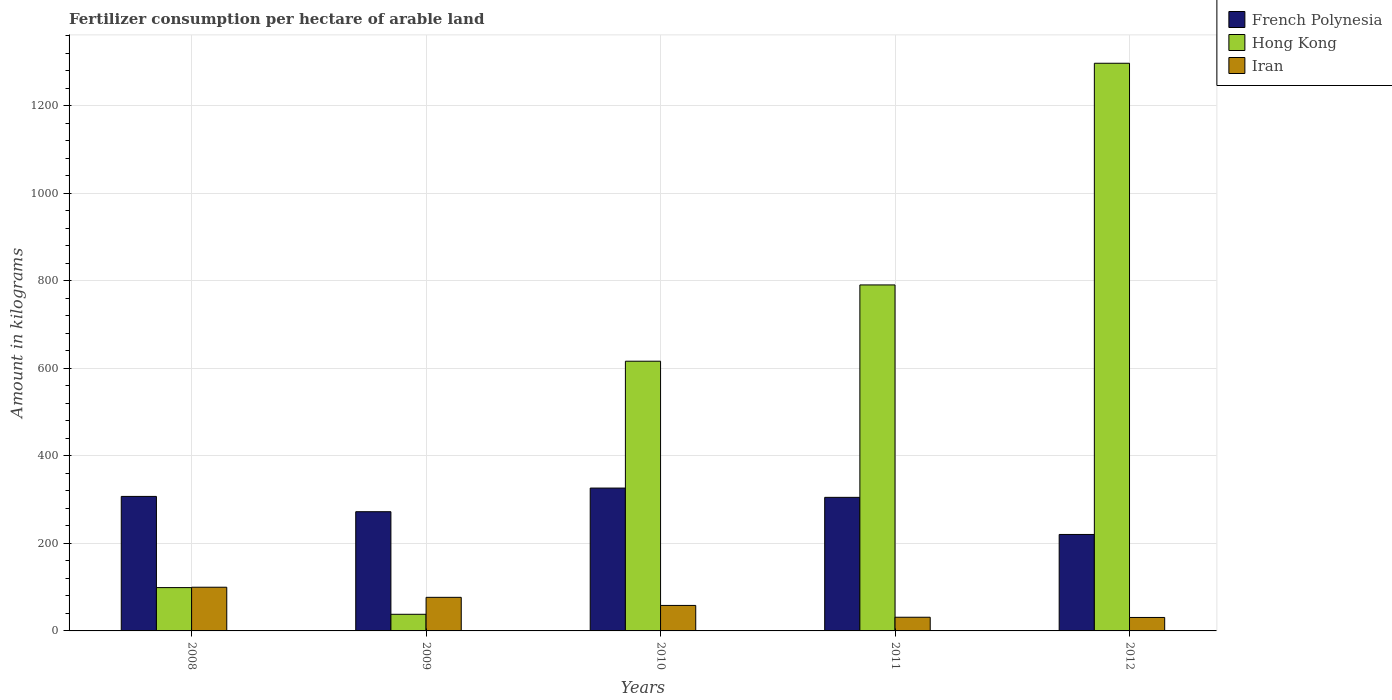How many bars are there on the 1st tick from the left?
Your response must be concise. 3. How many bars are there on the 2nd tick from the right?
Ensure brevity in your answer.  3. What is the label of the 5th group of bars from the left?
Keep it short and to the point. 2012. What is the amount of fertilizer consumption in French Polynesia in 2009?
Give a very brief answer. 272.4. Across all years, what is the maximum amount of fertilizer consumption in Hong Kong?
Your answer should be compact. 1297.1. Across all years, what is the minimum amount of fertilizer consumption in Hong Kong?
Give a very brief answer. 38. In which year was the amount of fertilizer consumption in Iran minimum?
Provide a short and direct response. 2012. What is the total amount of fertilizer consumption in Iran in the graph?
Provide a succinct answer. 296.86. What is the difference between the amount of fertilizer consumption in Hong Kong in 2009 and that in 2010?
Provide a succinct answer. -578.29. What is the difference between the amount of fertilizer consumption in Hong Kong in 2010 and the amount of fertilizer consumption in French Polynesia in 2009?
Provide a succinct answer. 343.89. What is the average amount of fertilizer consumption in Iran per year?
Your answer should be very brief. 59.37. In the year 2012, what is the difference between the amount of fertilizer consumption in Iran and amount of fertilizer consumption in Hong Kong?
Make the answer very short. -1266.33. In how many years, is the amount of fertilizer consumption in Iran greater than 960 kg?
Provide a succinct answer. 0. What is the ratio of the amount of fertilizer consumption in French Polynesia in 2009 to that in 2011?
Your answer should be compact. 0.89. Is the amount of fertilizer consumption in Hong Kong in 2009 less than that in 2010?
Keep it short and to the point. Yes. Is the difference between the amount of fertilizer consumption in Iran in 2009 and 2010 greater than the difference between the amount of fertilizer consumption in Hong Kong in 2009 and 2010?
Offer a very short reply. Yes. What is the difference between the highest and the second highest amount of fertilizer consumption in Iran?
Provide a short and direct response. 23.1. What is the difference between the highest and the lowest amount of fertilizer consumption in Iran?
Offer a very short reply. 69.08. In how many years, is the amount of fertilizer consumption in Iran greater than the average amount of fertilizer consumption in Iran taken over all years?
Ensure brevity in your answer.  2. What does the 3rd bar from the left in 2008 represents?
Make the answer very short. Iran. What does the 3rd bar from the right in 2008 represents?
Your response must be concise. French Polynesia. Is it the case that in every year, the sum of the amount of fertilizer consumption in French Polynesia and amount of fertilizer consumption in Hong Kong is greater than the amount of fertilizer consumption in Iran?
Give a very brief answer. Yes. How many bars are there?
Provide a succinct answer. 15. Does the graph contain any zero values?
Provide a short and direct response. No. Does the graph contain grids?
Your response must be concise. Yes. Where does the legend appear in the graph?
Your response must be concise. Top right. What is the title of the graph?
Keep it short and to the point. Fertilizer consumption per hectare of arable land. What is the label or title of the Y-axis?
Your answer should be very brief. Amount in kilograms. What is the Amount in kilograms of French Polynesia in 2008?
Give a very brief answer. 307.33. What is the Amount in kilograms of Iran in 2008?
Your answer should be very brief. 99.85. What is the Amount in kilograms in French Polynesia in 2009?
Provide a short and direct response. 272.4. What is the Amount in kilograms of Iran in 2009?
Ensure brevity in your answer.  76.74. What is the Amount in kilograms in French Polynesia in 2010?
Make the answer very short. 326.4. What is the Amount in kilograms of Hong Kong in 2010?
Provide a succinct answer. 616.29. What is the Amount in kilograms of Iran in 2010?
Offer a terse response. 58.25. What is the Amount in kilograms in French Polynesia in 2011?
Your answer should be very brief. 305.2. What is the Amount in kilograms of Hong Kong in 2011?
Make the answer very short. 790.57. What is the Amount in kilograms in Iran in 2011?
Your answer should be very brief. 31.26. What is the Amount in kilograms in French Polynesia in 2012?
Your answer should be very brief. 220.4. What is the Amount in kilograms in Hong Kong in 2012?
Offer a very short reply. 1297.1. What is the Amount in kilograms of Iran in 2012?
Provide a short and direct response. 30.76. Across all years, what is the maximum Amount in kilograms of French Polynesia?
Your answer should be very brief. 326.4. Across all years, what is the maximum Amount in kilograms in Hong Kong?
Your response must be concise. 1297.1. Across all years, what is the maximum Amount in kilograms of Iran?
Keep it short and to the point. 99.85. Across all years, what is the minimum Amount in kilograms of French Polynesia?
Your response must be concise. 220.4. Across all years, what is the minimum Amount in kilograms of Iran?
Ensure brevity in your answer.  30.76. What is the total Amount in kilograms of French Polynesia in the graph?
Your response must be concise. 1431.73. What is the total Amount in kilograms in Hong Kong in the graph?
Give a very brief answer. 2840.95. What is the total Amount in kilograms of Iran in the graph?
Offer a very short reply. 296.86. What is the difference between the Amount in kilograms of French Polynesia in 2008 and that in 2009?
Ensure brevity in your answer.  34.93. What is the difference between the Amount in kilograms of Iran in 2008 and that in 2009?
Give a very brief answer. 23.1. What is the difference between the Amount in kilograms of French Polynesia in 2008 and that in 2010?
Provide a succinct answer. -19.07. What is the difference between the Amount in kilograms of Hong Kong in 2008 and that in 2010?
Provide a short and direct response. -517.29. What is the difference between the Amount in kilograms in Iran in 2008 and that in 2010?
Ensure brevity in your answer.  41.6. What is the difference between the Amount in kilograms in French Polynesia in 2008 and that in 2011?
Give a very brief answer. 2.13. What is the difference between the Amount in kilograms of Hong Kong in 2008 and that in 2011?
Ensure brevity in your answer.  -691.57. What is the difference between the Amount in kilograms of Iran in 2008 and that in 2011?
Keep it short and to the point. 68.59. What is the difference between the Amount in kilograms of French Polynesia in 2008 and that in 2012?
Your answer should be compact. 86.93. What is the difference between the Amount in kilograms in Hong Kong in 2008 and that in 2012?
Your response must be concise. -1198.1. What is the difference between the Amount in kilograms in Iran in 2008 and that in 2012?
Give a very brief answer. 69.08. What is the difference between the Amount in kilograms of French Polynesia in 2009 and that in 2010?
Provide a short and direct response. -54. What is the difference between the Amount in kilograms in Hong Kong in 2009 and that in 2010?
Give a very brief answer. -578.29. What is the difference between the Amount in kilograms of Iran in 2009 and that in 2010?
Keep it short and to the point. 18.49. What is the difference between the Amount in kilograms in French Polynesia in 2009 and that in 2011?
Ensure brevity in your answer.  -32.8. What is the difference between the Amount in kilograms of Hong Kong in 2009 and that in 2011?
Ensure brevity in your answer.  -752.57. What is the difference between the Amount in kilograms in Iran in 2009 and that in 2011?
Provide a short and direct response. 45.48. What is the difference between the Amount in kilograms in Hong Kong in 2009 and that in 2012?
Make the answer very short. -1259.1. What is the difference between the Amount in kilograms of Iran in 2009 and that in 2012?
Make the answer very short. 45.98. What is the difference between the Amount in kilograms of French Polynesia in 2010 and that in 2011?
Make the answer very short. 21.2. What is the difference between the Amount in kilograms in Hong Kong in 2010 and that in 2011?
Keep it short and to the point. -174.29. What is the difference between the Amount in kilograms in Iran in 2010 and that in 2011?
Your response must be concise. 26.99. What is the difference between the Amount in kilograms in French Polynesia in 2010 and that in 2012?
Keep it short and to the point. 106. What is the difference between the Amount in kilograms in Hong Kong in 2010 and that in 2012?
Your answer should be very brief. -680.81. What is the difference between the Amount in kilograms in Iran in 2010 and that in 2012?
Your answer should be compact. 27.49. What is the difference between the Amount in kilograms of French Polynesia in 2011 and that in 2012?
Your response must be concise. 84.8. What is the difference between the Amount in kilograms of Hong Kong in 2011 and that in 2012?
Your response must be concise. -506.53. What is the difference between the Amount in kilograms in Iran in 2011 and that in 2012?
Provide a short and direct response. 0.5. What is the difference between the Amount in kilograms in French Polynesia in 2008 and the Amount in kilograms in Hong Kong in 2009?
Ensure brevity in your answer.  269.33. What is the difference between the Amount in kilograms in French Polynesia in 2008 and the Amount in kilograms in Iran in 2009?
Give a very brief answer. 230.59. What is the difference between the Amount in kilograms in Hong Kong in 2008 and the Amount in kilograms in Iran in 2009?
Provide a succinct answer. 22.26. What is the difference between the Amount in kilograms of French Polynesia in 2008 and the Amount in kilograms of Hong Kong in 2010?
Make the answer very short. -308.95. What is the difference between the Amount in kilograms of French Polynesia in 2008 and the Amount in kilograms of Iran in 2010?
Your answer should be compact. 249.08. What is the difference between the Amount in kilograms of Hong Kong in 2008 and the Amount in kilograms of Iran in 2010?
Your answer should be compact. 40.75. What is the difference between the Amount in kilograms in French Polynesia in 2008 and the Amount in kilograms in Hong Kong in 2011?
Keep it short and to the point. -483.24. What is the difference between the Amount in kilograms in French Polynesia in 2008 and the Amount in kilograms in Iran in 2011?
Provide a short and direct response. 276.07. What is the difference between the Amount in kilograms in Hong Kong in 2008 and the Amount in kilograms in Iran in 2011?
Your answer should be very brief. 67.74. What is the difference between the Amount in kilograms in French Polynesia in 2008 and the Amount in kilograms in Hong Kong in 2012?
Offer a terse response. -989.76. What is the difference between the Amount in kilograms in French Polynesia in 2008 and the Amount in kilograms in Iran in 2012?
Offer a terse response. 276.57. What is the difference between the Amount in kilograms of Hong Kong in 2008 and the Amount in kilograms of Iran in 2012?
Provide a succinct answer. 68.24. What is the difference between the Amount in kilograms of French Polynesia in 2009 and the Amount in kilograms of Hong Kong in 2010?
Your answer should be very brief. -343.89. What is the difference between the Amount in kilograms in French Polynesia in 2009 and the Amount in kilograms in Iran in 2010?
Provide a succinct answer. 214.15. What is the difference between the Amount in kilograms in Hong Kong in 2009 and the Amount in kilograms in Iran in 2010?
Your response must be concise. -20.25. What is the difference between the Amount in kilograms of French Polynesia in 2009 and the Amount in kilograms of Hong Kong in 2011?
Offer a terse response. -518.17. What is the difference between the Amount in kilograms of French Polynesia in 2009 and the Amount in kilograms of Iran in 2011?
Your response must be concise. 241.14. What is the difference between the Amount in kilograms in Hong Kong in 2009 and the Amount in kilograms in Iran in 2011?
Make the answer very short. 6.74. What is the difference between the Amount in kilograms of French Polynesia in 2009 and the Amount in kilograms of Hong Kong in 2012?
Your answer should be very brief. -1024.7. What is the difference between the Amount in kilograms in French Polynesia in 2009 and the Amount in kilograms in Iran in 2012?
Offer a terse response. 241.64. What is the difference between the Amount in kilograms of Hong Kong in 2009 and the Amount in kilograms of Iran in 2012?
Your answer should be compact. 7.24. What is the difference between the Amount in kilograms of French Polynesia in 2010 and the Amount in kilograms of Hong Kong in 2011?
Your answer should be very brief. -464.17. What is the difference between the Amount in kilograms in French Polynesia in 2010 and the Amount in kilograms in Iran in 2011?
Give a very brief answer. 295.14. What is the difference between the Amount in kilograms of Hong Kong in 2010 and the Amount in kilograms of Iran in 2011?
Offer a terse response. 585.03. What is the difference between the Amount in kilograms in French Polynesia in 2010 and the Amount in kilograms in Hong Kong in 2012?
Your answer should be compact. -970.7. What is the difference between the Amount in kilograms in French Polynesia in 2010 and the Amount in kilograms in Iran in 2012?
Keep it short and to the point. 295.64. What is the difference between the Amount in kilograms in Hong Kong in 2010 and the Amount in kilograms in Iran in 2012?
Give a very brief answer. 585.52. What is the difference between the Amount in kilograms in French Polynesia in 2011 and the Amount in kilograms in Hong Kong in 2012?
Provide a succinct answer. -991.9. What is the difference between the Amount in kilograms in French Polynesia in 2011 and the Amount in kilograms in Iran in 2012?
Offer a very short reply. 274.44. What is the difference between the Amount in kilograms of Hong Kong in 2011 and the Amount in kilograms of Iran in 2012?
Your response must be concise. 759.81. What is the average Amount in kilograms of French Polynesia per year?
Provide a short and direct response. 286.35. What is the average Amount in kilograms of Hong Kong per year?
Provide a succinct answer. 568.19. What is the average Amount in kilograms of Iran per year?
Keep it short and to the point. 59.37. In the year 2008, what is the difference between the Amount in kilograms in French Polynesia and Amount in kilograms in Hong Kong?
Your response must be concise. 208.33. In the year 2008, what is the difference between the Amount in kilograms in French Polynesia and Amount in kilograms in Iran?
Make the answer very short. 207.49. In the year 2008, what is the difference between the Amount in kilograms in Hong Kong and Amount in kilograms in Iran?
Your answer should be compact. -0.85. In the year 2009, what is the difference between the Amount in kilograms in French Polynesia and Amount in kilograms in Hong Kong?
Provide a succinct answer. 234.4. In the year 2009, what is the difference between the Amount in kilograms in French Polynesia and Amount in kilograms in Iran?
Give a very brief answer. 195.66. In the year 2009, what is the difference between the Amount in kilograms in Hong Kong and Amount in kilograms in Iran?
Keep it short and to the point. -38.74. In the year 2010, what is the difference between the Amount in kilograms of French Polynesia and Amount in kilograms of Hong Kong?
Your answer should be compact. -289.89. In the year 2010, what is the difference between the Amount in kilograms of French Polynesia and Amount in kilograms of Iran?
Your response must be concise. 268.15. In the year 2010, what is the difference between the Amount in kilograms in Hong Kong and Amount in kilograms in Iran?
Offer a very short reply. 558.04. In the year 2011, what is the difference between the Amount in kilograms of French Polynesia and Amount in kilograms of Hong Kong?
Offer a terse response. -485.37. In the year 2011, what is the difference between the Amount in kilograms of French Polynesia and Amount in kilograms of Iran?
Your response must be concise. 273.94. In the year 2011, what is the difference between the Amount in kilograms of Hong Kong and Amount in kilograms of Iran?
Provide a short and direct response. 759.31. In the year 2012, what is the difference between the Amount in kilograms of French Polynesia and Amount in kilograms of Hong Kong?
Ensure brevity in your answer.  -1076.7. In the year 2012, what is the difference between the Amount in kilograms of French Polynesia and Amount in kilograms of Iran?
Ensure brevity in your answer.  189.64. In the year 2012, what is the difference between the Amount in kilograms in Hong Kong and Amount in kilograms in Iran?
Ensure brevity in your answer.  1266.33. What is the ratio of the Amount in kilograms in French Polynesia in 2008 to that in 2009?
Your response must be concise. 1.13. What is the ratio of the Amount in kilograms of Hong Kong in 2008 to that in 2009?
Your response must be concise. 2.61. What is the ratio of the Amount in kilograms of Iran in 2008 to that in 2009?
Provide a short and direct response. 1.3. What is the ratio of the Amount in kilograms in French Polynesia in 2008 to that in 2010?
Your answer should be very brief. 0.94. What is the ratio of the Amount in kilograms in Hong Kong in 2008 to that in 2010?
Provide a succinct answer. 0.16. What is the ratio of the Amount in kilograms in Iran in 2008 to that in 2010?
Give a very brief answer. 1.71. What is the ratio of the Amount in kilograms in Hong Kong in 2008 to that in 2011?
Your answer should be compact. 0.13. What is the ratio of the Amount in kilograms of Iran in 2008 to that in 2011?
Offer a terse response. 3.19. What is the ratio of the Amount in kilograms of French Polynesia in 2008 to that in 2012?
Your response must be concise. 1.39. What is the ratio of the Amount in kilograms in Hong Kong in 2008 to that in 2012?
Offer a terse response. 0.08. What is the ratio of the Amount in kilograms of Iran in 2008 to that in 2012?
Your answer should be compact. 3.25. What is the ratio of the Amount in kilograms of French Polynesia in 2009 to that in 2010?
Give a very brief answer. 0.83. What is the ratio of the Amount in kilograms of Hong Kong in 2009 to that in 2010?
Offer a very short reply. 0.06. What is the ratio of the Amount in kilograms in Iran in 2009 to that in 2010?
Offer a very short reply. 1.32. What is the ratio of the Amount in kilograms in French Polynesia in 2009 to that in 2011?
Keep it short and to the point. 0.89. What is the ratio of the Amount in kilograms in Hong Kong in 2009 to that in 2011?
Give a very brief answer. 0.05. What is the ratio of the Amount in kilograms of Iran in 2009 to that in 2011?
Keep it short and to the point. 2.46. What is the ratio of the Amount in kilograms of French Polynesia in 2009 to that in 2012?
Your response must be concise. 1.24. What is the ratio of the Amount in kilograms of Hong Kong in 2009 to that in 2012?
Give a very brief answer. 0.03. What is the ratio of the Amount in kilograms in Iran in 2009 to that in 2012?
Your answer should be compact. 2.49. What is the ratio of the Amount in kilograms in French Polynesia in 2010 to that in 2011?
Provide a short and direct response. 1.07. What is the ratio of the Amount in kilograms in Hong Kong in 2010 to that in 2011?
Offer a very short reply. 0.78. What is the ratio of the Amount in kilograms in Iran in 2010 to that in 2011?
Your response must be concise. 1.86. What is the ratio of the Amount in kilograms of French Polynesia in 2010 to that in 2012?
Keep it short and to the point. 1.48. What is the ratio of the Amount in kilograms of Hong Kong in 2010 to that in 2012?
Give a very brief answer. 0.48. What is the ratio of the Amount in kilograms of Iran in 2010 to that in 2012?
Make the answer very short. 1.89. What is the ratio of the Amount in kilograms of French Polynesia in 2011 to that in 2012?
Keep it short and to the point. 1.38. What is the ratio of the Amount in kilograms in Hong Kong in 2011 to that in 2012?
Your response must be concise. 0.61. What is the ratio of the Amount in kilograms of Iran in 2011 to that in 2012?
Your answer should be compact. 1.02. What is the difference between the highest and the second highest Amount in kilograms of French Polynesia?
Provide a short and direct response. 19.07. What is the difference between the highest and the second highest Amount in kilograms in Hong Kong?
Offer a terse response. 506.53. What is the difference between the highest and the second highest Amount in kilograms of Iran?
Make the answer very short. 23.1. What is the difference between the highest and the lowest Amount in kilograms of French Polynesia?
Keep it short and to the point. 106. What is the difference between the highest and the lowest Amount in kilograms in Hong Kong?
Keep it short and to the point. 1259.1. What is the difference between the highest and the lowest Amount in kilograms in Iran?
Your response must be concise. 69.08. 